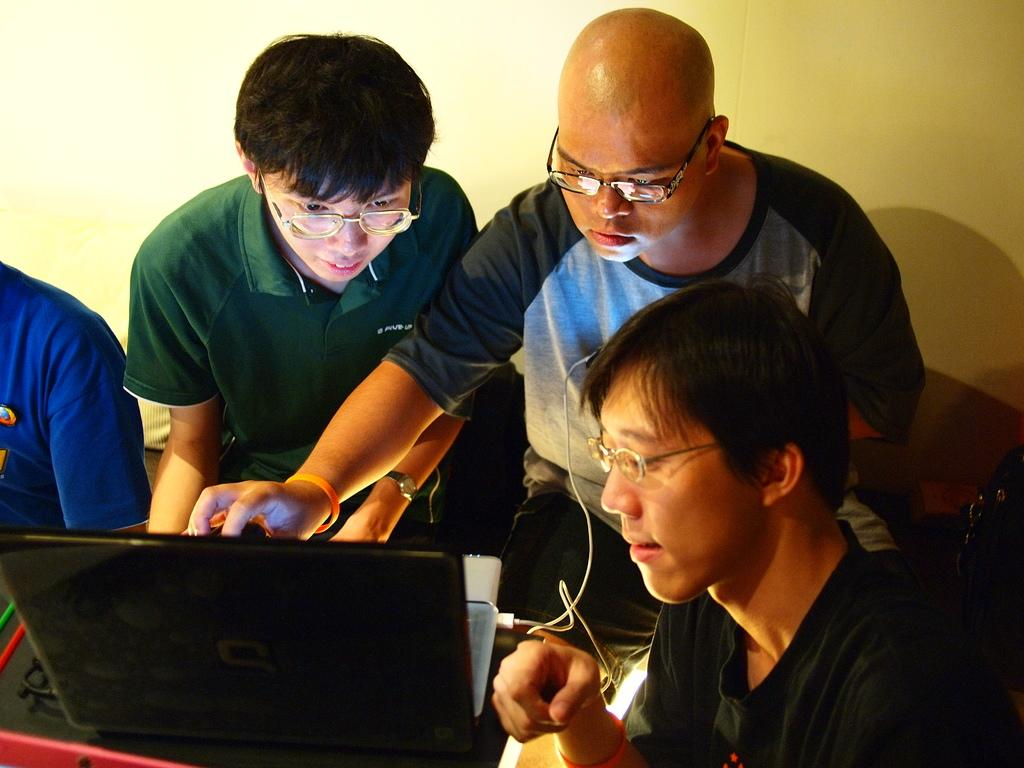What piece of furniture is visible in the image? There is a table in the image. What electronic device is on the table? A laptop is present on the table. Who is at the table in the image? There are people sitting around the table. What can be seen in the background of the image? There is a wall in the background of the image. Is there a door in the image, and if so, where is it located? There is no door present in the image. What type of flag is being waved by the people sitting around the table? There is no flag present in the image. 